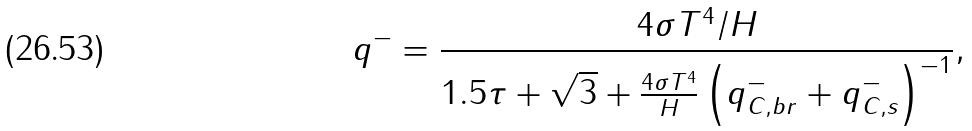Convert formula to latex. <formula><loc_0><loc_0><loc_500><loc_500>q ^ { - } = \frac { 4 \sigma T ^ { 4 } / H } { 1 . 5 \tau + \sqrt { 3 } + \frac { 4 \sigma T ^ { 4 } } { H } \left ( q ^ { - } _ { C , b r } + q ^ { - } _ { C , s } \right ) ^ { - 1 } } ,</formula> 